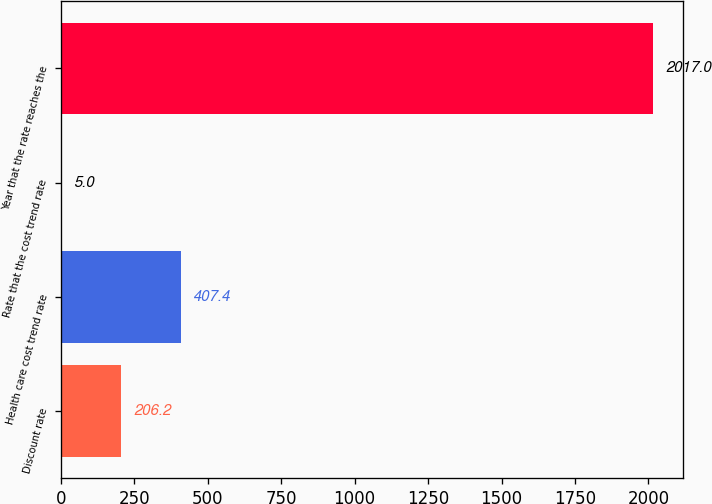Convert chart. <chart><loc_0><loc_0><loc_500><loc_500><bar_chart><fcel>Discount rate<fcel>Health care cost trend rate<fcel>Rate that the cost trend rate<fcel>Year that the rate reaches the<nl><fcel>206.2<fcel>407.4<fcel>5<fcel>2017<nl></chart> 